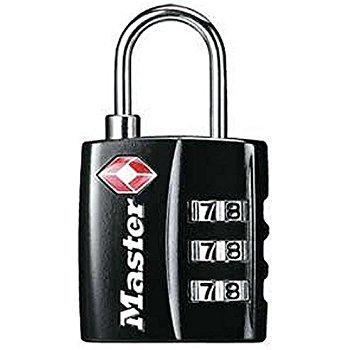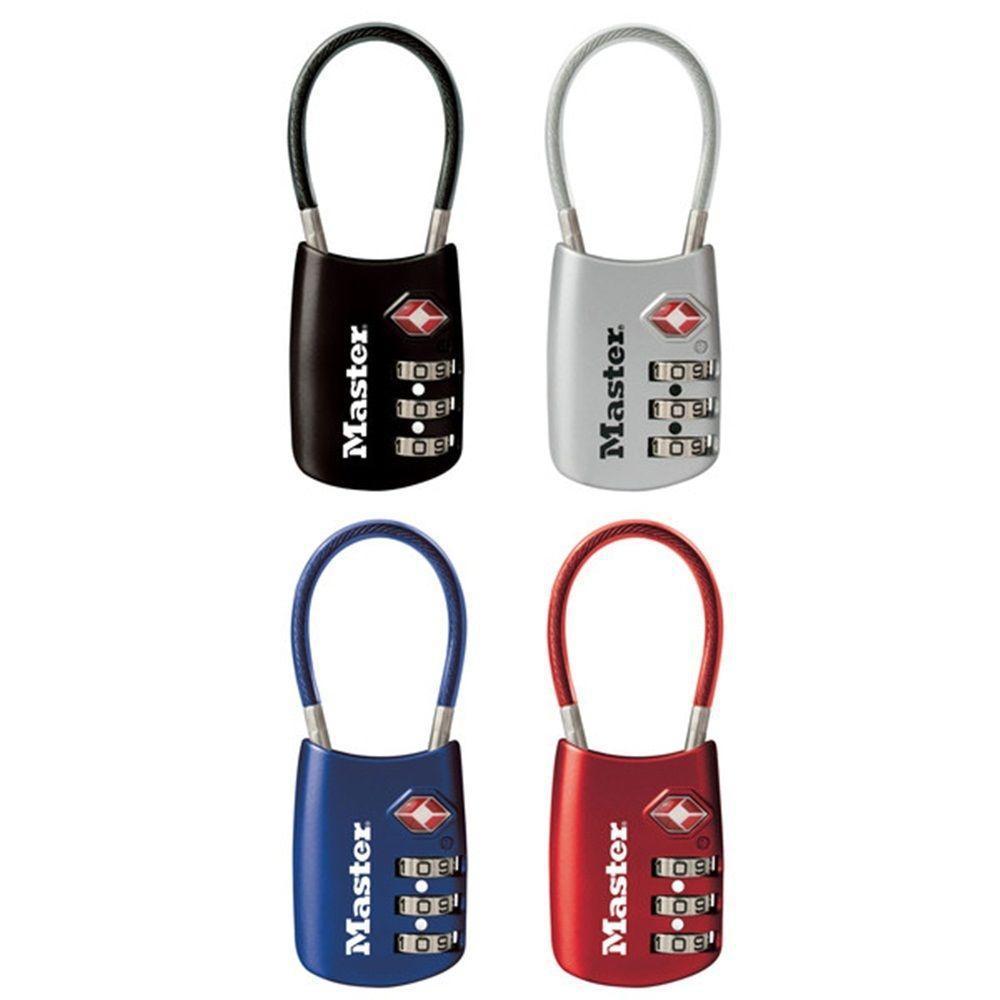The first image is the image on the left, the second image is the image on the right. Considering the images on both sides, is "All locks have a loop on the top and exactly three rows of number belts on the front of the lock." valid? Answer yes or no. Yes. The first image is the image on the left, the second image is the image on the right. Considering the images on both sides, is "An image features exactly one combination lock, which is black." valid? Answer yes or no. Yes. 